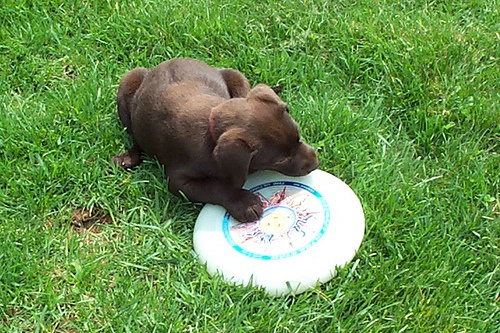Describe the objects in this image and their specific colors. I can see dog in darkgreen, black, gray, and darkgray tones and frisbee in darkgreen, white, lightblue, darkgray, and gray tones in this image. 